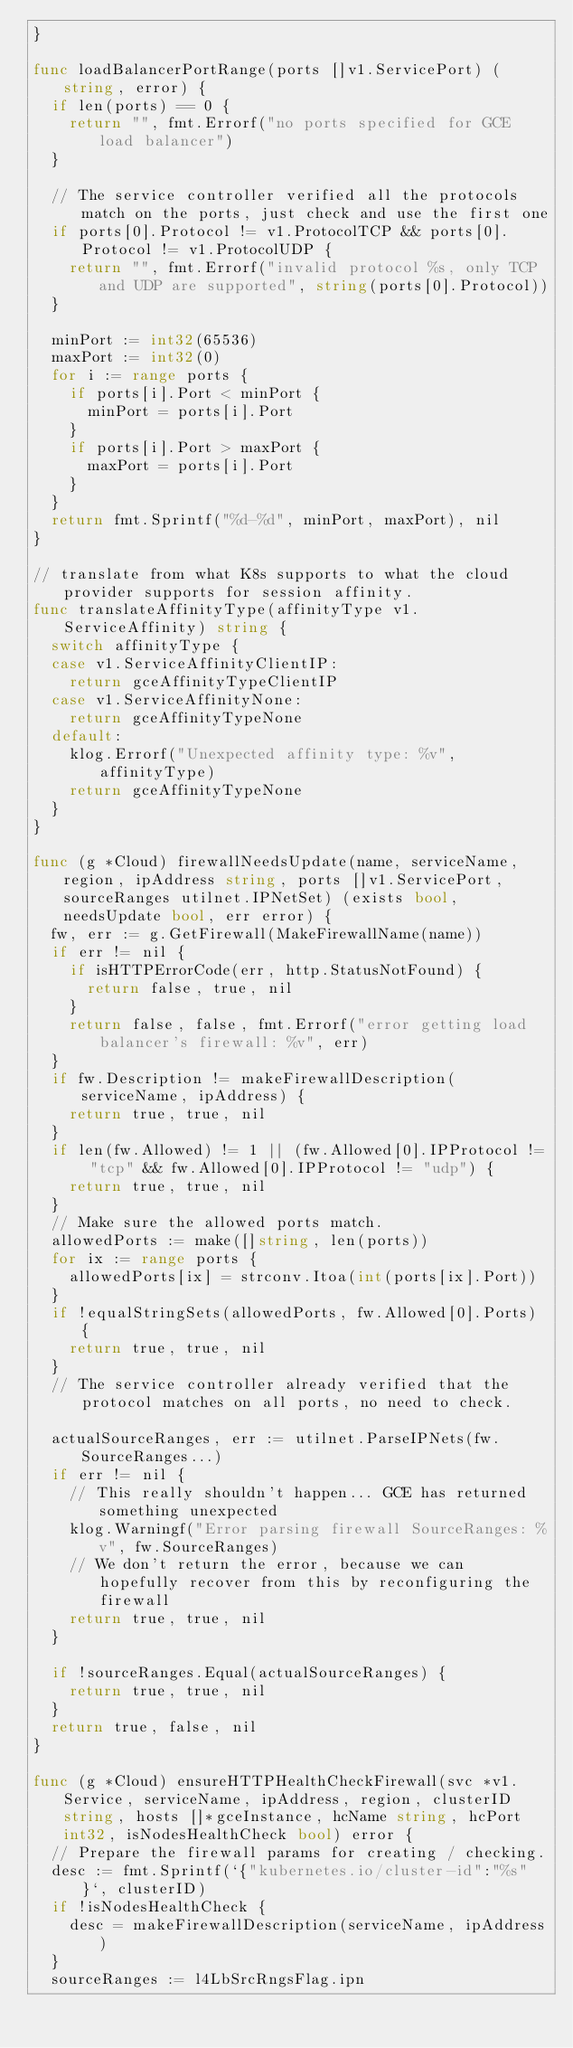<code> <loc_0><loc_0><loc_500><loc_500><_Go_>}

func loadBalancerPortRange(ports []v1.ServicePort) (string, error) {
	if len(ports) == 0 {
		return "", fmt.Errorf("no ports specified for GCE load balancer")
	}

	// The service controller verified all the protocols match on the ports, just check and use the first one
	if ports[0].Protocol != v1.ProtocolTCP && ports[0].Protocol != v1.ProtocolUDP {
		return "", fmt.Errorf("invalid protocol %s, only TCP and UDP are supported", string(ports[0].Protocol))
	}

	minPort := int32(65536)
	maxPort := int32(0)
	for i := range ports {
		if ports[i].Port < minPort {
			minPort = ports[i].Port
		}
		if ports[i].Port > maxPort {
			maxPort = ports[i].Port
		}
	}
	return fmt.Sprintf("%d-%d", minPort, maxPort), nil
}

// translate from what K8s supports to what the cloud provider supports for session affinity.
func translateAffinityType(affinityType v1.ServiceAffinity) string {
	switch affinityType {
	case v1.ServiceAffinityClientIP:
		return gceAffinityTypeClientIP
	case v1.ServiceAffinityNone:
		return gceAffinityTypeNone
	default:
		klog.Errorf("Unexpected affinity type: %v", affinityType)
		return gceAffinityTypeNone
	}
}

func (g *Cloud) firewallNeedsUpdate(name, serviceName, region, ipAddress string, ports []v1.ServicePort, sourceRanges utilnet.IPNetSet) (exists bool, needsUpdate bool, err error) {
	fw, err := g.GetFirewall(MakeFirewallName(name))
	if err != nil {
		if isHTTPErrorCode(err, http.StatusNotFound) {
			return false, true, nil
		}
		return false, false, fmt.Errorf("error getting load balancer's firewall: %v", err)
	}
	if fw.Description != makeFirewallDescription(serviceName, ipAddress) {
		return true, true, nil
	}
	if len(fw.Allowed) != 1 || (fw.Allowed[0].IPProtocol != "tcp" && fw.Allowed[0].IPProtocol != "udp") {
		return true, true, nil
	}
	// Make sure the allowed ports match.
	allowedPorts := make([]string, len(ports))
	for ix := range ports {
		allowedPorts[ix] = strconv.Itoa(int(ports[ix].Port))
	}
	if !equalStringSets(allowedPorts, fw.Allowed[0].Ports) {
		return true, true, nil
	}
	// The service controller already verified that the protocol matches on all ports, no need to check.

	actualSourceRanges, err := utilnet.ParseIPNets(fw.SourceRanges...)
	if err != nil {
		// This really shouldn't happen... GCE has returned something unexpected
		klog.Warningf("Error parsing firewall SourceRanges: %v", fw.SourceRanges)
		// We don't return the error, because we can hopefully recover from this by reconfiguring the firewall
		return true, true, nil
	}

	if !sourceRanges.Equal(actualSourceRanges) {
		return true, true, nil
	}
	return true, false, nil
}

func (g *Cloud) ensureHTTPHealthCheckFirewall(svc *v1.Service, serviceName, ipAddress, region, clusterID string, hosts []*gceInstance, hcName string, hcPort int32, isNodesHealthCheck bool) error {
	// Prepare the firewall params for creating / checking.
	desc := fmt.Sprintf(`{"kubernetes.io/cluster-id":"%s"}`, clusterID)
	if !isNodesHealthCheck {
		desc = makeFirewallDescription(serviceName, ipAddress)
	}
	sourceRanges := l4LbSrcRngsFlag.ipn</code> 